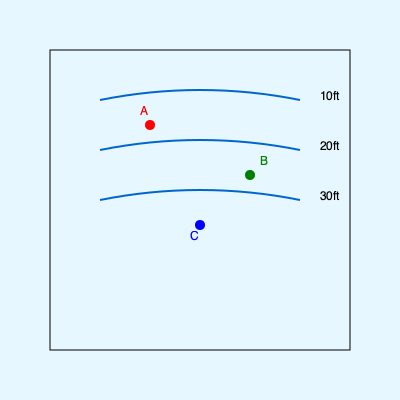Based on the lake depth contour map, which spot (A, B, or C) is likely to be the best fishing location for catching larger fish that prefer deeper waters? To determine the best fishing spot for larger fish that prefer deeper waters, we need to analyze the depth contours on the map:

1. Interpret the contour lines:
   - The curved lines represent depth contours.
   - Each line represents a specific depth, with deeper areas towards the center of the lake.

2. Identify the depths:
   - The top line is labeled 10ft
   - The middle line is labeled 20ft
   - The bottom line is labeled 30ft

3. Locate the fishing spots:
   - Spot A (red) is between the 10ft and 20ft contour lines
   - Spot B (green) is just below the 20ft contour line
   - Spot C (blue) is below the 30ft contour line

4. Consider fish behavior:
   - Larger fish often prefer deeper waters for various reasons, including cooler temperatures and access to smaller fish as prey.

5. Compare the spots:
   - Spot A is in the shallowest area among the three
   - Spot B is in a moderately deep area
   - Spot C is in the deepest area among the three

Given that larger fish prefer deeper waters, Spot C, being in the deepest area (below 30ft), is likely to be the best fishing location for catching larger fish.
Answer: C 